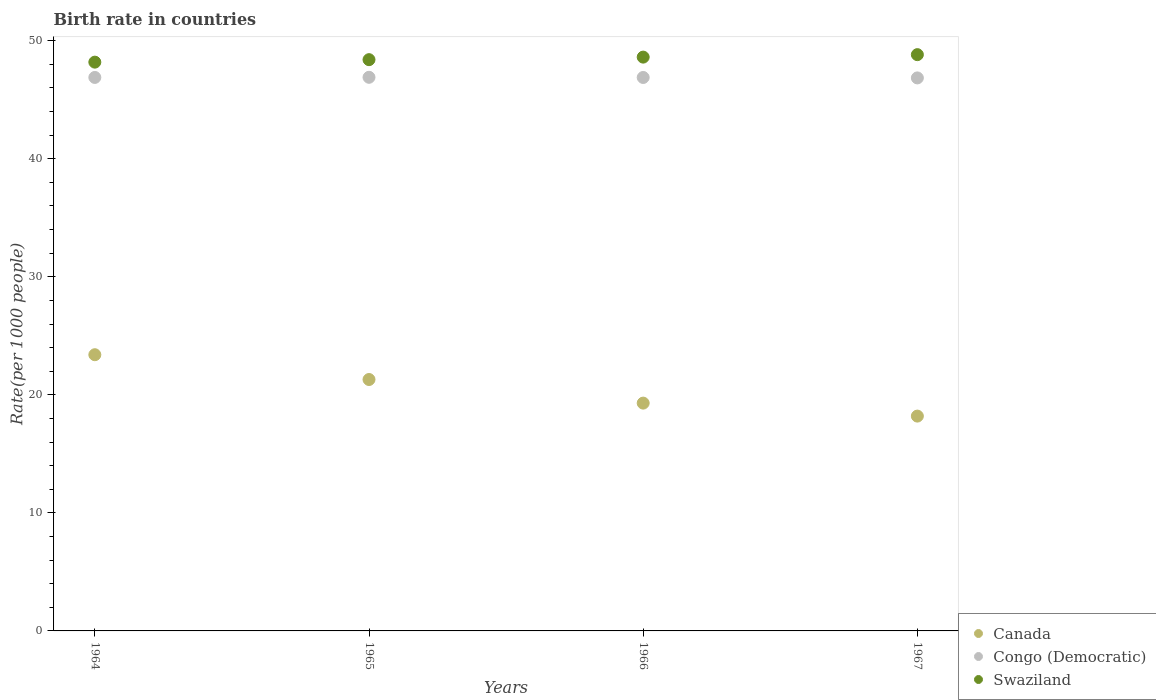What is the birth rate in Swaziland in 1967?
Your answer should be compact. 48.82. Across all years, what is the maximum birth rate in Swaziland?
Offer a terse response. 48.82. Across all years, what is the minimum birth rate in Congo (Democratic)?
Ensure brevity in your answer.  46.85. In which year was the birth rate in Congo (Democratic) maximum?
Provide a short and direct response. 1965. In which year was the birth rate in Congo (Democratic) minimum?
Your answer should be compact. 1967. What is the total birth rate in Swaziland in the graph?
Ensure brevity in your answer.  194.02. What is the difference between the birth rate in Canada in 1965 and that in 1966?
Your answer should be compact. 2. What is the difference between the birth rate in Canada in 1966 and the birth rate in Swaziland in 1964?
Your answer should be very brief. -28.89. What is the average birth rate in Canada per year?
Your answer should be very brief. 20.55. In the year 1966, what is the difference between the birth rate in Congo (Democratic) and birth rate in Canada?
Provide a succinct answer. 27.59. In how many years, is the birth rate in Canada greater than 32?
Provide a short and direct response. 0. What is the ratio of the birth rate in Canada in 1966 to that in 1967?
Provide a short and direct response. 1.06. What is the difference between the highest and the second highest birth rate in Canada?
Ensure brevity in your answer.  2.1. What is the difference between the highest and the lowest birth rate in Swaziland?
Provide a succinct answer. 0.64. Is it the case that in every year, the sum of the birth rate in Congo (Democratic) and birth rate in Swaziland  is greater than the birth rate in Canada?
Provide a succinct answer. Yes. How many dotlines are there?
Provide a short and direct response. 3. How many years are there in the graph?
Offer a very short reply. 4. Are the values on the major ticks of Y-axis written in scientific E-notation?
Your answer should be very brief. No. Where does the legend appear in the graph?
Provide a succinct answer. Bottom right. What is the title of the graph?
Your response must be concise. Birth rate in countries. Does "Guinea" appear as one of the legend labels in the graph?
Your answer should be very brief. No. What is the label or title of the X-axis?
Your answer should be very brief. Years. What is the label or title of the Y-axis?
Provide a succinct answer. Rate(per 1000 people). What is the Rate(per 1000 people) in Canada in 1964?
Offer a terse response. 23.4. What is the Rate(per 1000 people) of Congo (Democratic) in 1964?
Your answer should be very brief. 46.89. What is the Rate(per 1000 people) of Swaziland in 1964?
Ensure brevity in your answer.  48.19. What is the Rate(per 1000 people) in Canada in 1965?
Provide a short and direct response. 21.3. What is the Rate(per 1000 people) in Congo (Democratic) in 1965?
Ensure brevity in your answer.  46.9. What is the Rate(per 1000 people) of Swaziland in 1965?
Your response must be concise. 48.4. What is the Rate(per 1000 people) of Canada in 1966?
Your answer should be very brief. 19.3. What is the Rate(per 1000 people) in Congo (Democratic) in 1966?
Provide a short and direct response. 46.89. What is the Rate(per 1000 people) of Swaziland in 1966?
Offer a very short reply. 48.61. What is the Rate(per 1000 people) in Canada in 1967?
Offer a very short reply. 18.2. What is the Rate(per 1000 people) in Congo (Democratic) in 1967?
Offer a terse response. 46.85. What is the Rate(per 1000 people) in Swaziland in 1967?
Provide a succinct answer. 48.82. Across all years, what is the maximum Rate(per 1000 people) in Canada?
Ensure brevity in your answer.  23.4. Across all years, what is the maximum Rate(per 1000 people) in Congo (Democratic)?
Provide a succinct answer. 46.9. Across all years, what is the maximum Rate(per 1000 people) of Swaziland?
Give a very brief answer. 48.82. Across all years, what is the minimum Rate(per 1000 people) in Canada?
Ensure brevity in your answer.  18.2. Across all years, what is the minimum Rate(per 1000 people) in Congo (Democratic)?
Offer a terse response. 46.85. Across all years, what is the minimum Rate(per 1000 people) of Swaziland?
Your response must be concise. 48.19. What is the total Rate(per 1000 people) in Canada in the graph?
Your answer should be compact. 82.2. What is the total Rate(per 1000 people) of Congo (Democratic) in the graph?
Keep it short and to the point. 187.53. What is the total Rate(per 1000 people) of Swaziland in the graph?
Ensure brevity in your answer.  194.02. What is the difference between the Rate(per 1000 people) of Congo (Democratic) in 1964 and that in 1965?
Your answer should be very brief. -0.01. What is the difference between the Rate(per 1000 people) of Swaziland in 1964 and that in 1965?
Your answer should be very brief. -0.21. What is the difference between the Rate(per 1000 people) of Congo (Democratic) in 1964 and that in 1966?
Keep it short and to the point. 0. What is the difference between the Rate(per 1000 people) in Swaziland in 1964 and that in 1966?
Your response must be concise. -0.43. What is the difference between the Rate(per 1000 people) of Congo (Democratic) in 1964 and that in 1967?
Your response must be concise. 0.04. What is the difference between the Rate(per 1000 people) in Swaziland in 1964 and that in 1967?
Provide a short and direct response. -0.64. What is the difference between the Rate(per 1000 people) of Congo (Democratic) in 1965 and that in 1966?
Your answer should be compact. 0.01. What is the difference between the Rate(per 1000 people) in Swaziland in 1965 and that in 1966?
Provide a succinct answer. -0.22. What is the difference between the Rate(per 1000 people) in Canada in 1965 and that in 1967?
Ensure brevity in your answer.  3.1. What is the difference between the Rate(per 1000 people) of Congo (Democratic) in 1965 and that in 1967?
Your answer should be very brief. 0.05. What is the difference between the Rate(per 1000 people) of Swaziland in 1965 and that in 1967?
Give a very brief answer. -0.42. What is the difference between the Rate(per 1000 people) of Congo (Democratic) in 1966 and that in 1967?
Keep it short and to the point. 0.04. What is the difference between the Rate(per 1000 people) of Swaziland in 1966 and that in 1967?
Offer a very short reply. -0.21. What is the difference between the Rate(per 1000 people) in Canada in 1964 and the Rate(per 1000 people) in Congo (Democratic) in 1965?
Your answer should be compact. -23.5. What is the difference between the Rate(per 1000 people) in Canada in 1964 and the Rate(per 1000 people) in Swaziland in 1965?
Give a very brief answer. -25. What is the difference between the Rate(per 1000 people) in Congo (Democratic) in 1964 and the Rate(per 1000 people) in Swaziland in 1965?
Your response must be concise. -1.51. What is the difference between the Rate(per 1000 people) of Canada in 1964 and the Rate(per 1000 people) of Congo (Democratic) in 1966?
Your answer should be very brief. -23.49. What is the difference between the Rate(per 1000 people) of Canada in 1964 and the Rate(per 1000 people) of Swaziland in 1966?
Provide a succinct answer. -25.21. What is the difference between the Rate(per 1000 people) of Congo (Democratic) in 1964 and the Rate(per 1000 people) of Swaziland in 1966?
Your response must be concise. -1.72. What is the difference between the Rate(per 1000 people) in Canada in 1964 and the Rate(per 1000 people) in Congo (Democratic) in 1967?
Offer a very short reply. -23.45. What is the difference between the Rate(per 1000 people) of Canada in 1964 and the Rate(per 1000 people) of Swaziland in 1967?
Offer a terse response. -25.42. What is the difference between the Rate(per 1000 people) in Congo (Democratic) in 1964 and the Rate(per 1000 people) in Swaziland in 1967?
Make the answer very short. -1.93. What is the difference between the Rate(per 1000 people) of Canada in 1965 and the Rate(per 1000 people) of Congo (Democratic) in 1966?
Offer a very short reply. -25.59. What is the difference between the Rate(per 1000 people) in Canada in 1965 and the Rate(per 1000 people) in Swaziland in 1966?
Provide a succinct answer. -27.31. What is the difference between the Rate(per 1000 people) of Congo (Democratic) in 1965 and the Rate(per 1000 people) of Swaziland in 1966?
Keep it short and to the point. -1.71. What is the difference between the Rate(per 1000 people) in Canada in 1965 and the Rate(per 1000 people) in Congo (Democratic) in 1967?
Your answer should be compact. -25.55. What is the difference between the Rate(per 1000 people) in Canada in 1965 and the Rate(per 1000 people) in Swaziland in 1967?
Your response must be concise. -27.52. What is the difference between the Rate(per 1000 people) of Congo (Democratic) in 1965 and the Rate(per 1000 people) of Swaziland in 1967?
Provide a succinct answer. -1.92. What is the difference between the Rate(per 1000 people) of Canada in 1966 and the Rate(per 1000 people) of Congo (Democratic) in 1967?
Provide a short and direct response. -27.55. What is the difference between the Rate(per 1000 people) of Canada in 1966 and the Rate(per 1000 people) of Swaziland in 1967?
Your answer should be very brief. -29.52. What is the difference between the Rate(per 1000 people) of Congo (Democratic) in 1966 and the Rate(per 1000 people) of Swaziland in 1967?
Provide a succinct answer. -1.93. What is the average Rate(per 1000 people) in Canada per year?
Make the answer very short. 20.55. What is the average Rate(per 1000 people) in Congo (Democratic) per year?
Keep it short and to the point. 46.88. What is the average Rate(per 1000 people) of Swaziland per year?
Ensure brevity in your answer.  48.5. In the year 1964, what is the difference between the Rate(per 1000 people) of Canada and Rate(per 1000 people) of Congo (Democratic)?
Your answer should be compact. -23.49. In the year 1964, what is the difference between the Rate(per 1000 people) of Canada and Rate(per 1000 people) of Swaziland?
Make the answer very short. -24.79. In the year 1964, what is the difference between the Rate(per 1000 people) in Congo (Democratic) and Rate(per 1000 people) in Swaziland?
Your answer should be very brief. -1.3. In the year 1965, what is the difference between the Rate(per 1000 people) of Canada and Rate(per 1000 people) of Congo (Democratic)?
Offer a terse response. -25.6. In the year 1965, what is the difference between the Rate(per 1000 people) of Canada and Rate(per 1000 people) of Swaziland?
Ensure brevity in your answer.  -27.1. In the year 1965, what is the difference between the Rate(per 1000 people) in Congo (Democratic) and Rate(per 1000 people) in Swaziland?
Keep it short and to the point. -1.49. In the year 1966, what is the difference between the Rate(per 1000 people) in Canada and Rate(per 1000 people) in Congo (Democratic)?
Provide a succinct answer. -27.59. In the year 1966, what is the difference between the Rate(per 1000 people) of Canada and Rate(per 1000 people) of Swaziland?
Provide a succinct answer. -29.31. In the year 1966, what is the difference between the Rate(per 1000 people) in Congo (Democratic) and Rate(per 1000 people) in Swaziland?
Keep it short and to the point. -1.73. In the year 1967, what is the difference between the Rate(per 1000 people) of Canada and Rate(per 1000 people) of Congo (Democratic)?
Provide a succinct answer. -28.65. In the year 1967, what is the difference between the Rate(per 1000 people) of Canada and Rate(per 1000 people) of Swaziland?
Make the answer very short. -30.62. In the year 1967, what is the difference between the Rate(per 1000 people) of Congo (Democratic) and Rate(per 1000 people) of Swaziland?
Ensure brevity in your answer.  -1.97. What is the ratio of the Rate(per 1000 people) in Canada in 1964 to that in 1965?
Give a very brief answer. 1.1. What is the ratio of the Rate(per 1000 people) in Canada in 1964 to that in 1966?
Ensure brevity in your answer.  1.21. What is the ratio of the Rate(per 1000 people) in Swaziland in 1964 to that in 1967?
Your answer should be compact. 0.99. What is the ratio of the Rate(per 1000 people) in Canada in 1965 to that in 1966?
Make the answer very short. 1.1. What is the ratio of the Rate(per 1000 people) of Swaziland in 1965 to that in 1966?
Offer a terse response. 1. What is the ratio of the Rate(per 1000 people) in Canada in 1965 to that in 1967?
Keep it short and to the point. 1.17. What is the ratio of the Rate(per 1000 people) of Canada in 1966 to that in 1967?
Offer a terse response. 1.06. What is the ratio of the Rate(per 1000 people) of Congo (Democratic) in 1966 to that in 1967?
Provide a succinct answer. 1. What is the difference between the highest and the second highest Rate(per 1000 people) in Congo (Democratic)?
Provide a succinct answer. 0.01. What is the difference between the highest and the second highest Rate(per 1000 people) of Swaziland?
Keep it short and to the point. 0.21. What is the difference between the highest and the lowest Rate(per 1000 people) in Canada?
Make the answer very short. 5.2. What is the difference between the highest and the lowest Rate(per 1000 people) of Congo (Democratic)?
Ensure brevity in your answer.  0.05. What is the difference between the highest and the lowest Rate(per 1000 people) of Swaziland?
Offer a very short reply. 0.64. 